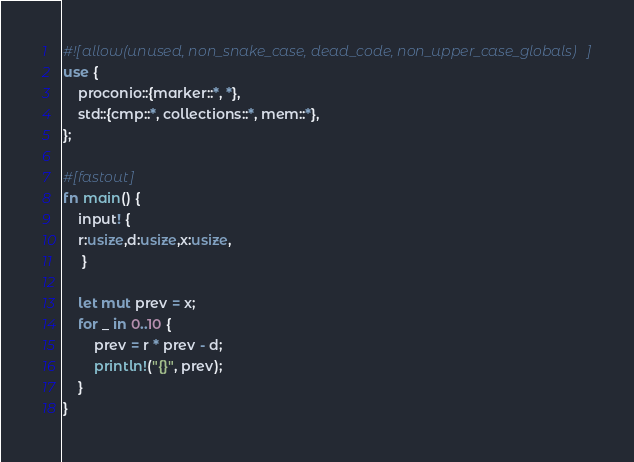<code> <loc_0><loc_0><loc_500><loc_500><_Rust_>#![allow(unused, non_snake_case, dead_code, non_upper_case_globals)]
use {
    proconio::{marker::*, *},
    std::{cmp::*, collections::*, mem::*},
};

#[fastout]
fn main() {
    input! {
    r:usize,d:usize,x:usize,
     }

    let mut prev = x;
    for _ in 0..10 {
        prev = r * prev - d;
        println!("{}", prev);
    }
}
</code> 